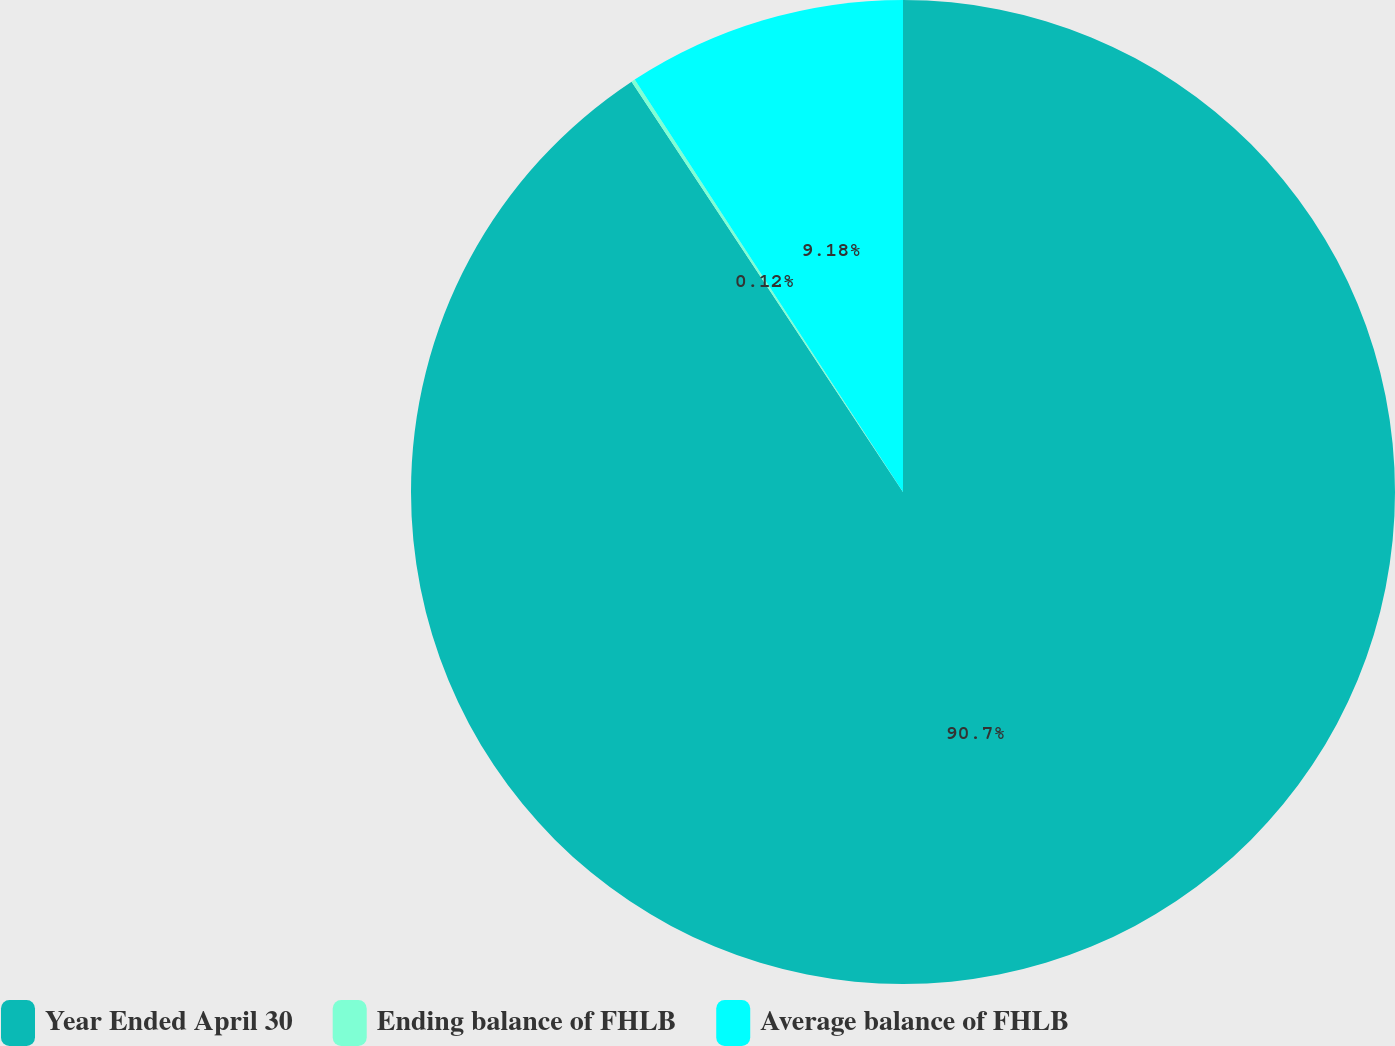<chart> <loc_0><loc_0><loc_500><loc_500><pie_chart><fcel>Year Ended April 30<fcel>Ending balance of FHLB<fcel>Average balance of FHLB<nl><fcel>90.7%<fcel>0.12%<fcel>9.18%<nl></chart> 